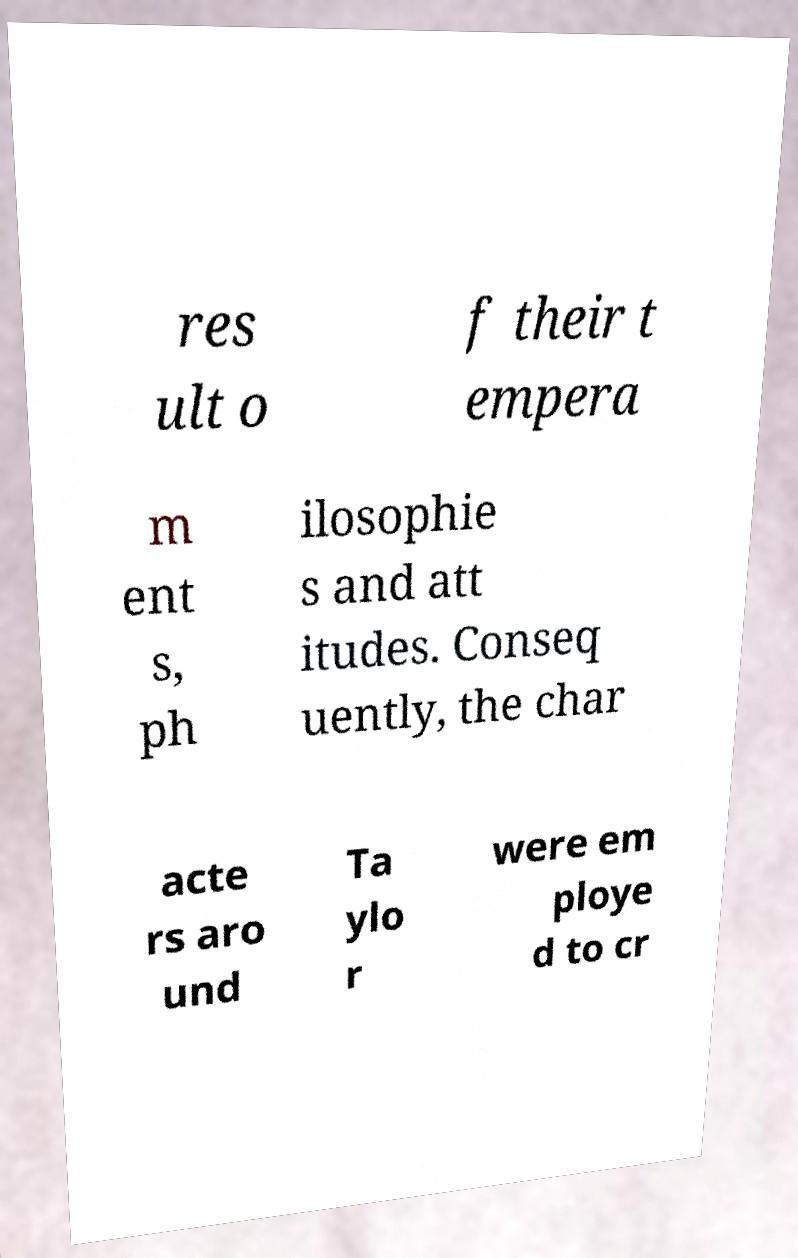Please identify and transcribe the text found in this image. res ult o f their t empera m ent s, ph ilosophie s and att itudes. Conseq uently, the char acte rs aro und Ta ylo r were em ploye d to cr 